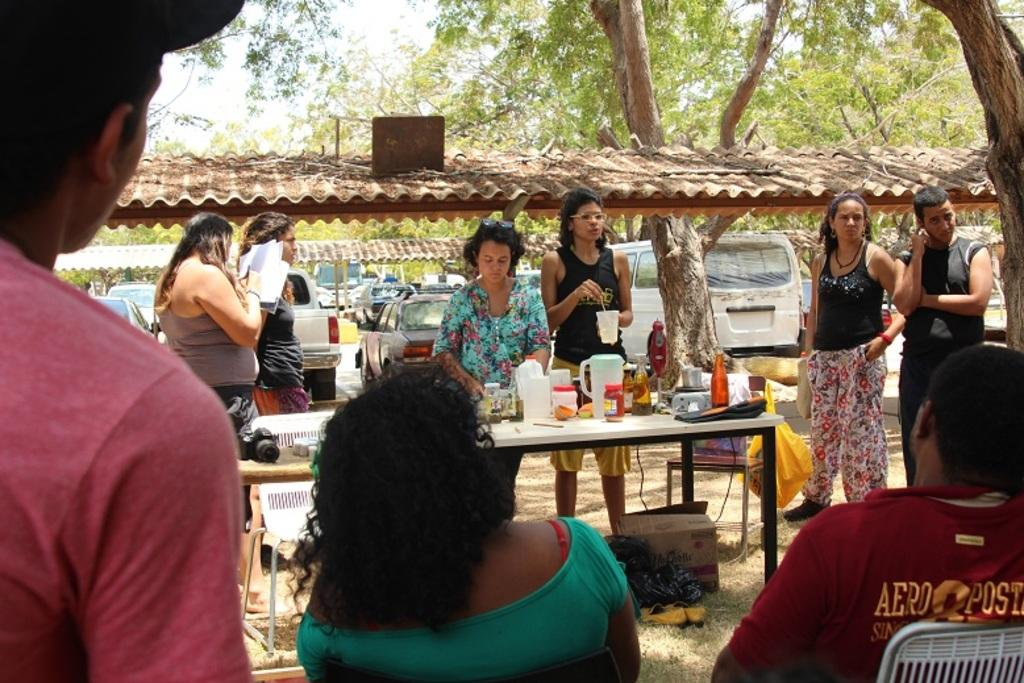How many people are present in the image? There are many people standing in the image. Are there any people sitting in the image? Yes, two people are sitting in the image. What are the people standing in front of? There are tables in front of the people. What can be found on the tables? There are many items on the tables. What type of natural scenery is visible in the image? There are trees visible in the image. What type of transportation can be seen in the image? There are many cars in the image. How many bulbs are hanging from the trees in the image? There are no bulbs hanging from the trees in the image; only trees are visible. What type of boats can be seen in the image? There are no boats present in the image. 